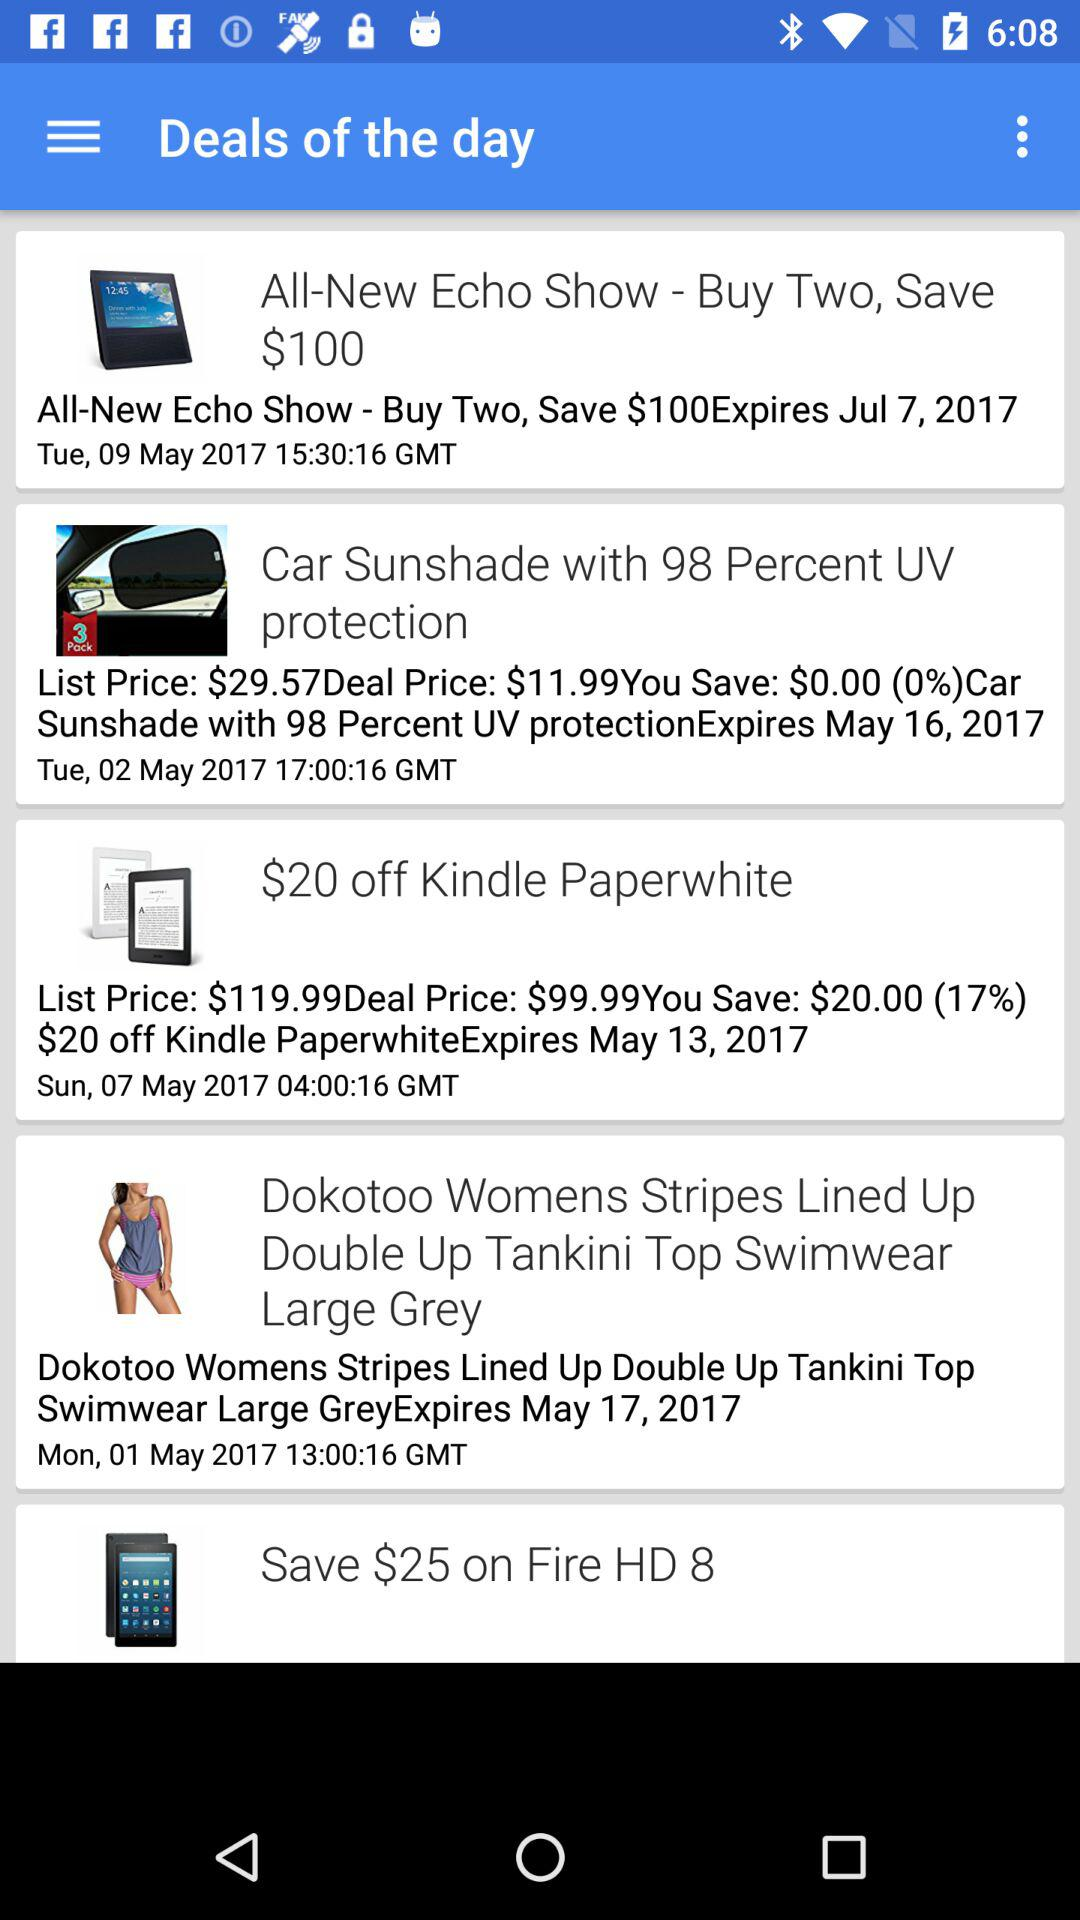How many $ can be saved on "Fire HD 8"? On "Fire HD 8", $25 can be saved. 